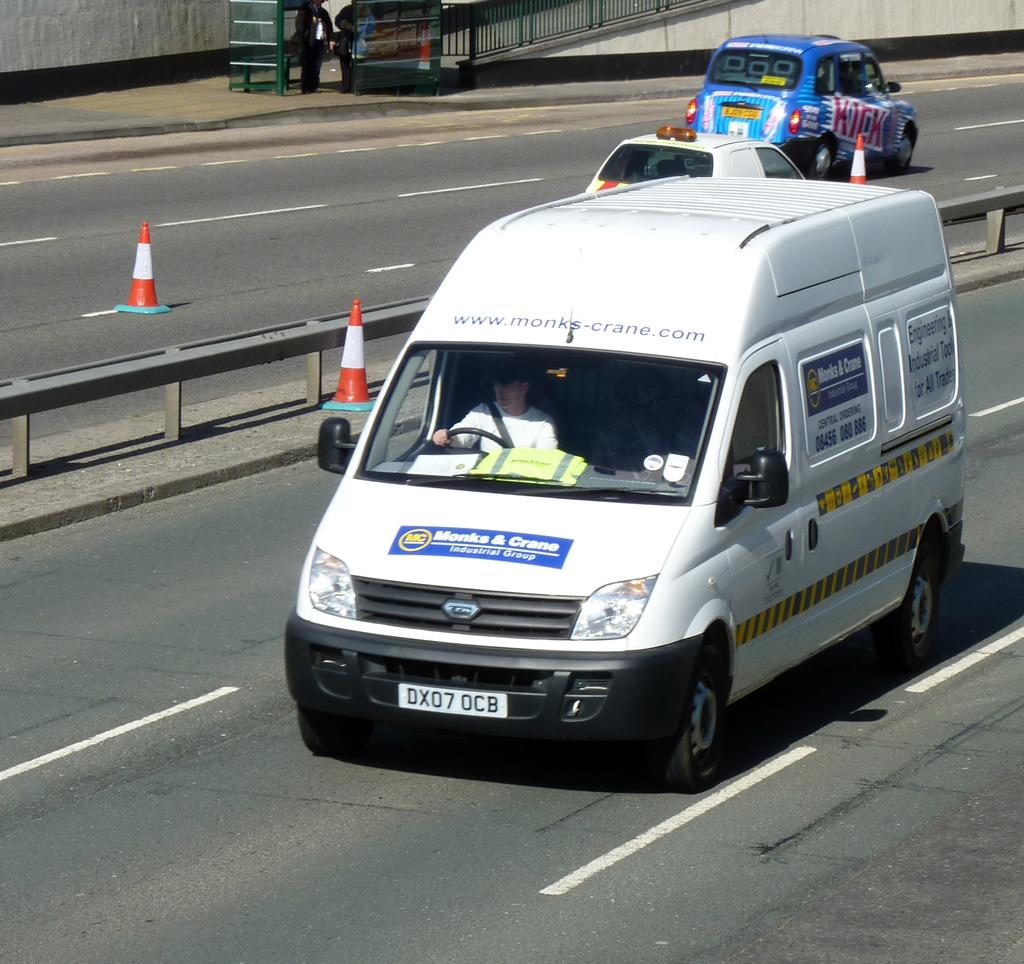Provide a one-sentence caption for the provided image. a white van on a highway from Monks & Crane. 